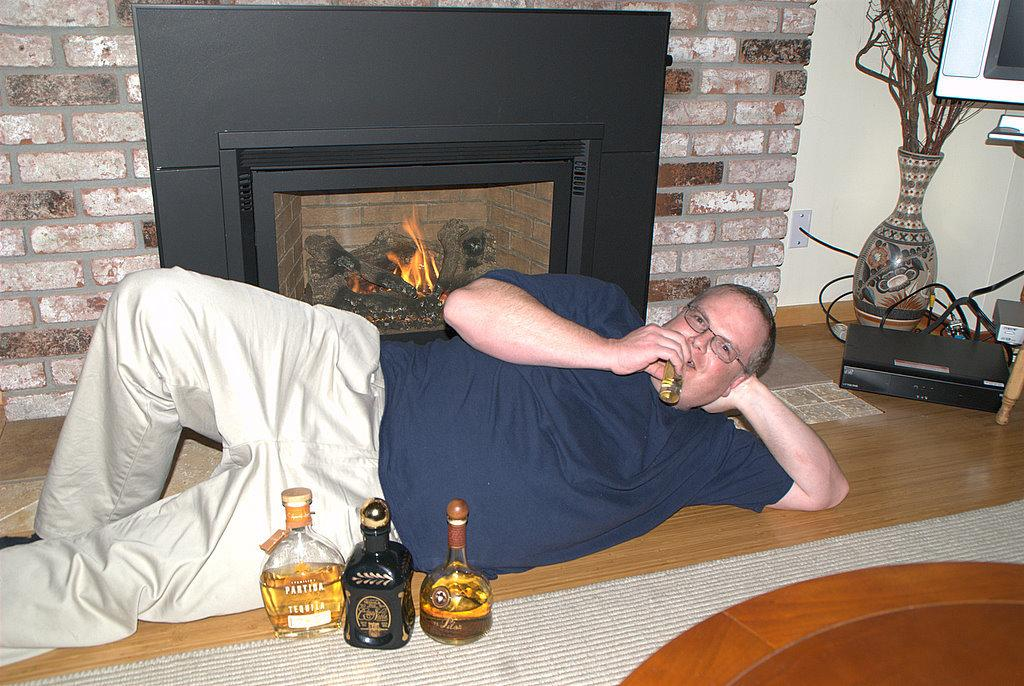What is the person in the image doing? The person is laying on the floor. What is the person holding in the image? The person is holding an object. How many bottles are on the carpet in the image? There are three bottles on the carpet. What furniture is present in the image? There is a table in the image. What type of plant is in the pot in the image? There is a show plant in the pot in the image. What type of electronic device is in the image? There is a television in the image. What architectural feature is present in the image? There is a fireplace in the image. What type of surface is visible in the image? There is a wall in the image. What additional details can be seen in the image? There are cables visible in the image. What type of cheese is being grated on the person's head in the image? There is no cheese present in the image, nor is there any cheese being grated on the person's head. 